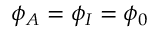<formula> <loc_0><loc_0><loc_500><loc_500>\phi _ { A } = \phi _ { I } = \phi _ { 0 }</formula> 